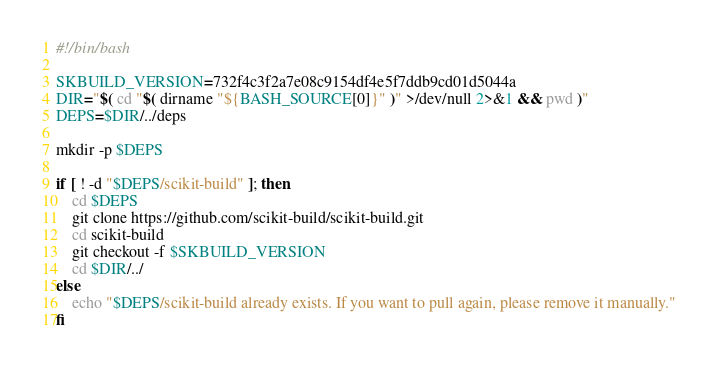Convert code to text. <code><loc_0><loc_0><loc_500><loc_500><_Bash_>#!/bin/bash

SKBUILD_VERSION=732f4c3f2a7e08c9154df4e5f7ddb9cd01d5044a
DIR="$( cd "$( dirname "${BASH_SOURCE[0]}" )" >/dev/null 2>&1 && pwd )"
DEPS=$DIR/../deps

mkdir -p $DEPS

if [ ! -d "$DEPS/scikit-build" ]; then
    cd $DEPS
    git clone https://github.com/scikit-build/scikit-build.git
    cd scikit-build
    git checkout -f $SKBUILD_VERSION
    cd $DIR/../
else
    echo "$DEPS/scikit-build already exists. If you want to pull again, please remove it manually."
fi
</code> 